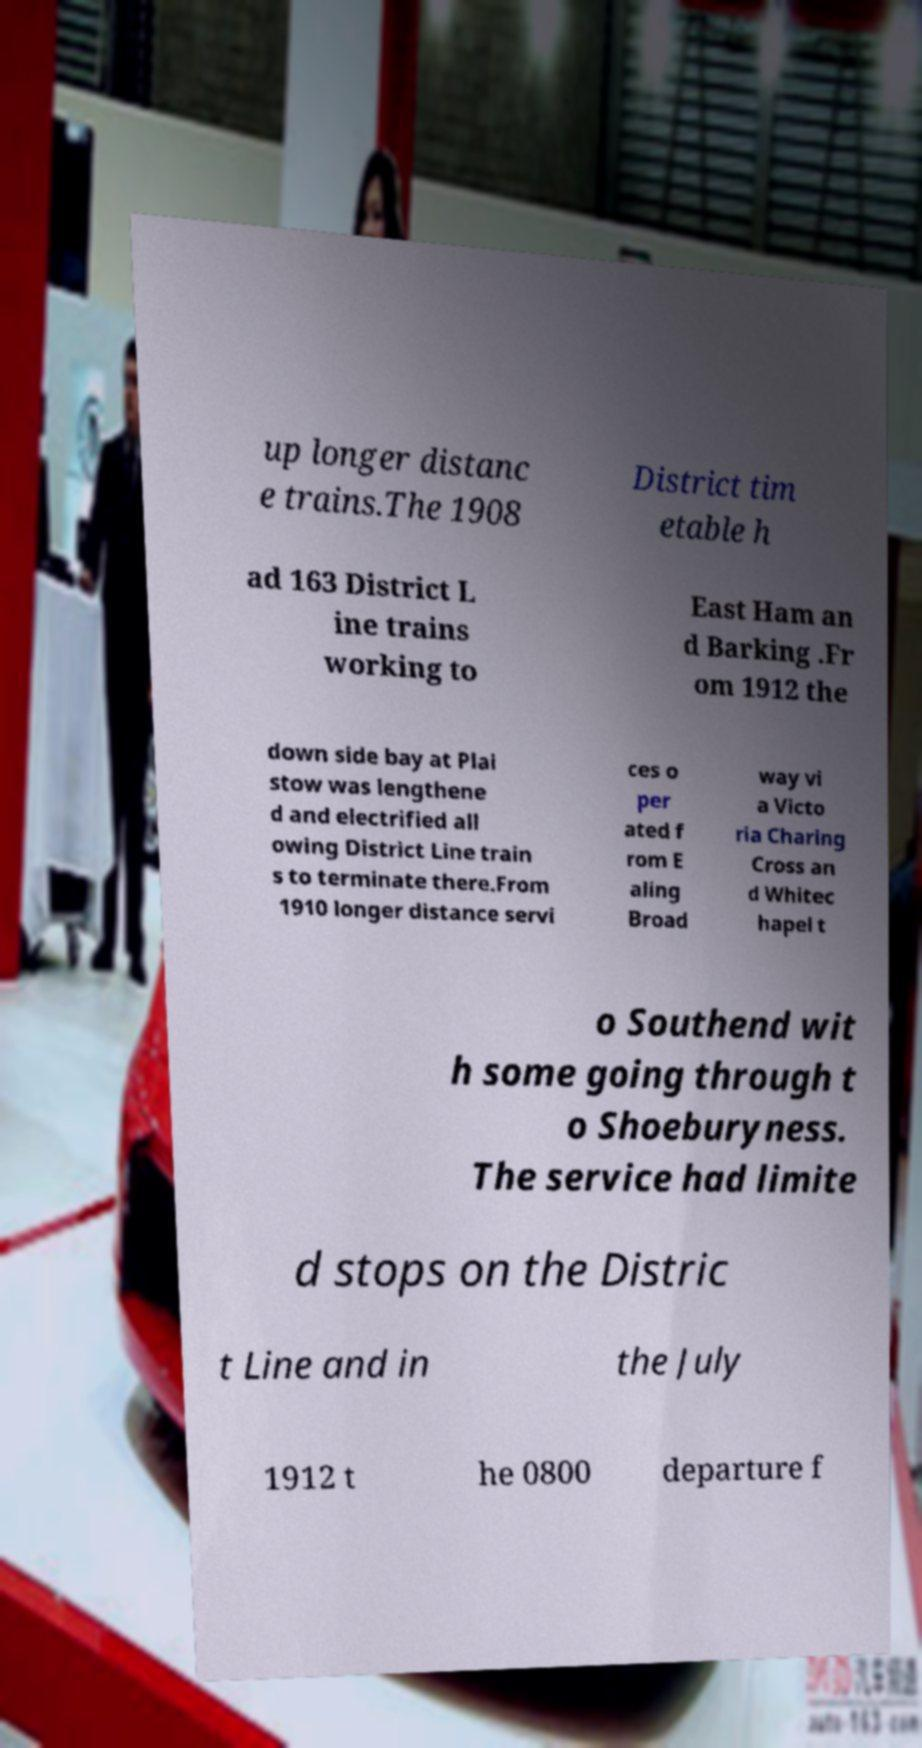Can you accurately transcribe the text from the provided image for me? up longer distanc e trains.The 1908 District tim etable h ad 163 District L ine trains working to East Ham an d Barking .Fr om 1912 the down side bay at Plai stow was lengthene d and electrified all owing District Line train s to terminate there.From 1910 longer distance servi ces o per ated f rom E aling Broad way vi a Victo ria Charing Cross an d Whitec hapel t o Southend wit h some going through t o Shoeburyness. The service had limite d stops on the Distric t Line and in the July 1912 t he 0800 departure f 